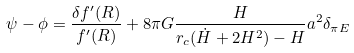Convert formula to latex. <formula><loc_0><loc_0><loc_500><loc_500>\psi - \phi = \frac { \delta f ^ { \prime } ( R ) } { f ^ { \prime } ( R ) } + 8 \pi G \frac { H } { r _ { c } ( \dot { H } + 2 H ^ { 2 } ) - H } a ^ { 2 } \delta _ { \pi E }</formula> 